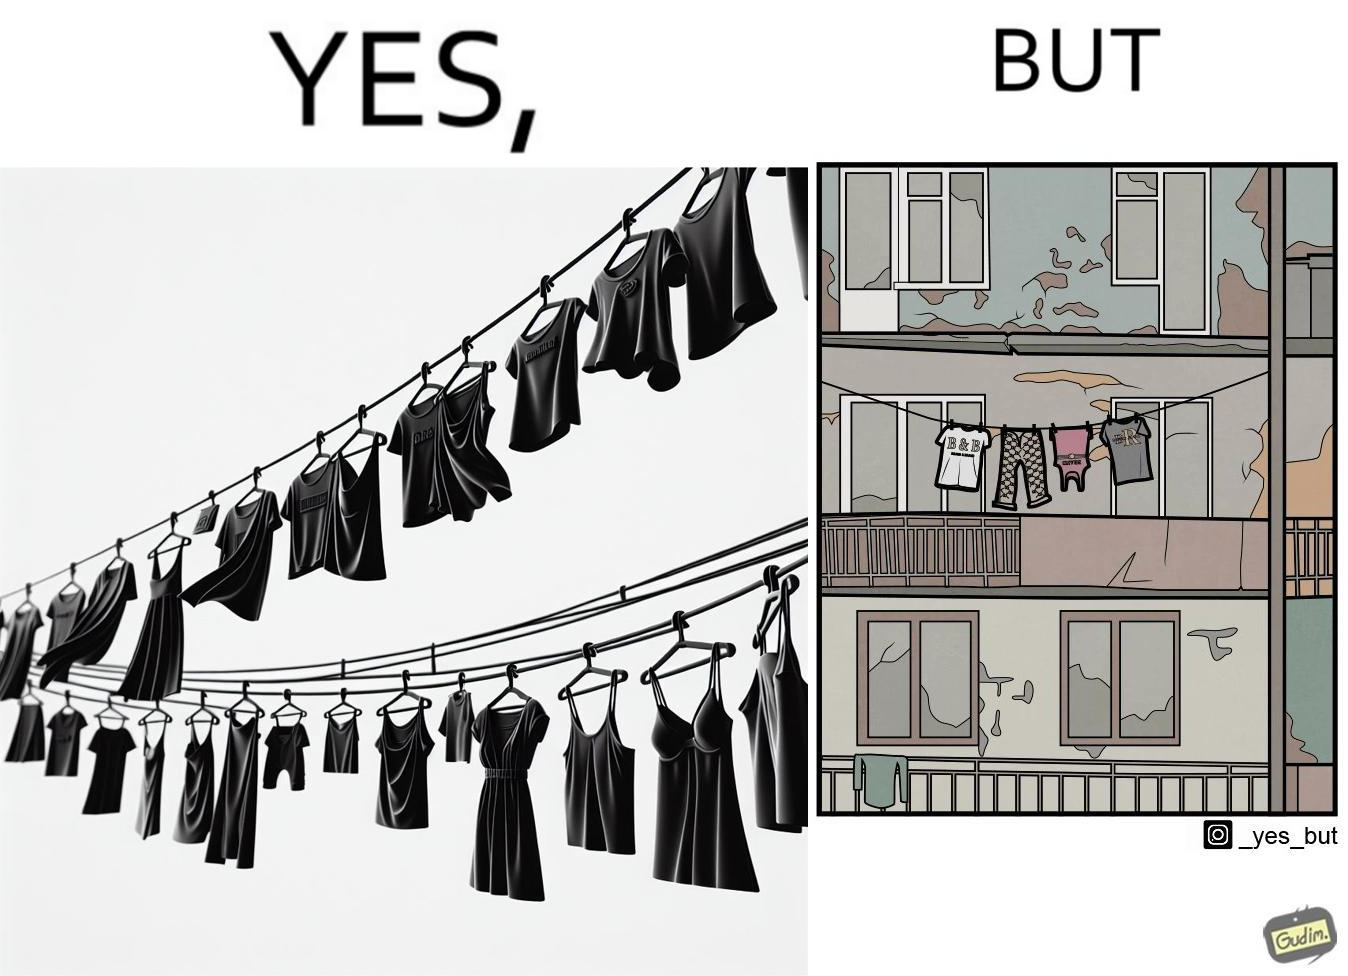Compare the left and right sides of this image. In the left part of the image: The image is showing branded clothes hanging on a wire. In the right part of the image: The image is showing a very old, dirty and broken house. 